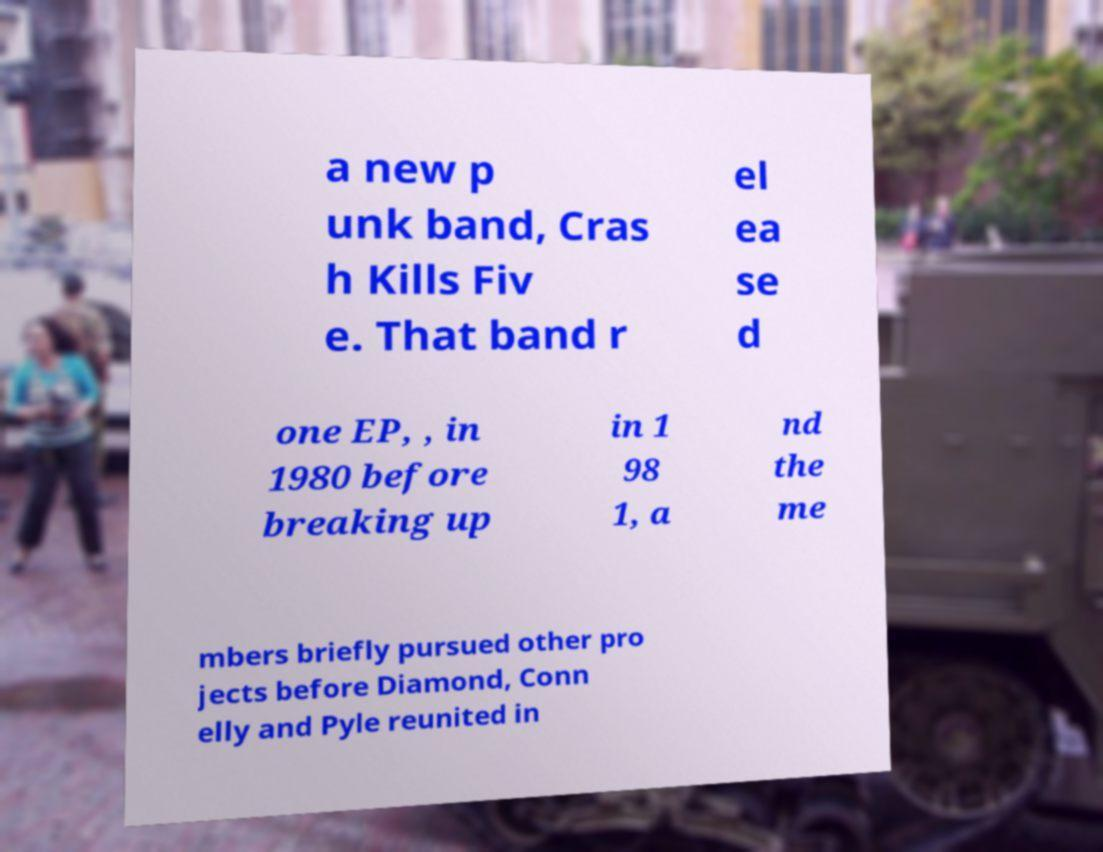Can you read and provide the text displayed in the image?This photo seems to have some interesting text. Can you extract and type it out for me? a new p unk band, Cras h Kills Fiv e. That band r el ea se d one EP, , in 1980 before breaking up in 1 98 1, a nd the me mbers briefly pursued other pro jects before Diamond, Conn elly and Pyle reunited in 